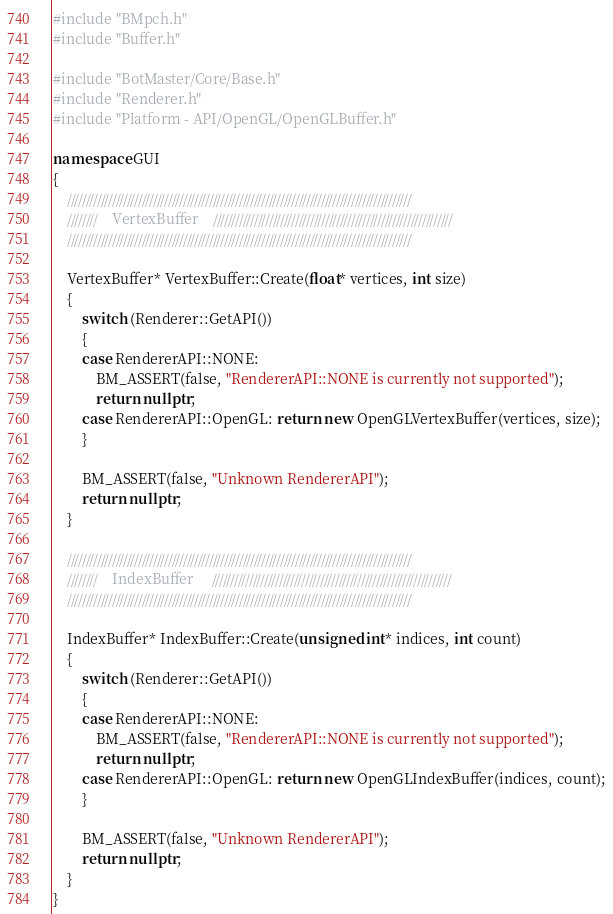Convert code to text. <code><loc_0><loc_0><loc_500><loc_500><_C++_>#include "BMpch.h"
#include "Buffer.h"

#include "BotMaster/Core/Base.h"
#include "Renderer.h"
#include "Platform - API/OpenGL/OpenGLBuffer.h"

namespace GUI
{
	////////////////////////////////////////////////////////////////////////////////////////////
	////////	VertexBuffer	////////////////////////////////////////////////////////////////
	////////////////////////////////////////////////////////////////////////////////////////////

	VertexBuffer* VertexBuffer::Create(float* vertices, int size)
	{
		switch (Renderer::GetAPI())
		{
		case RendererAPI::NONE:
			BM_ASSERT(false, "RendererAPI::NONE is currently not supported");
			return nullptr;
		case RendererAPI::OpenGL: return new OpenGLVertexBuffer(vertices, size);
		}

		BM_ASSERT(false, "Unknown RendererAPI");
		return nullptr;
	}

	////////////////////////////////////////////////////////////////////////////////////////////
	////////	IndexBuffer		////////////////////////////////////////////////////////////////
	////////////////////////////////////////////////////////////////////////////////////////////

	IndexBuffer* IndexBuffer::Create(unsigned int* indices, int count)
	{
		switch (Renderer::GetAPI())
		{
		case RendererAPI::NONE:
			BM_ASSERT(false, "RendererAPI::NONE is currently not supported");
			return nullptr;
		case RendererAPI::OpenGL: return new OpenGLIndexBuffer(indices, count);
		}

		BM_ASSERT(false, "Unknown RendererAPI");
		return nullptr;
	}
}
</code> 